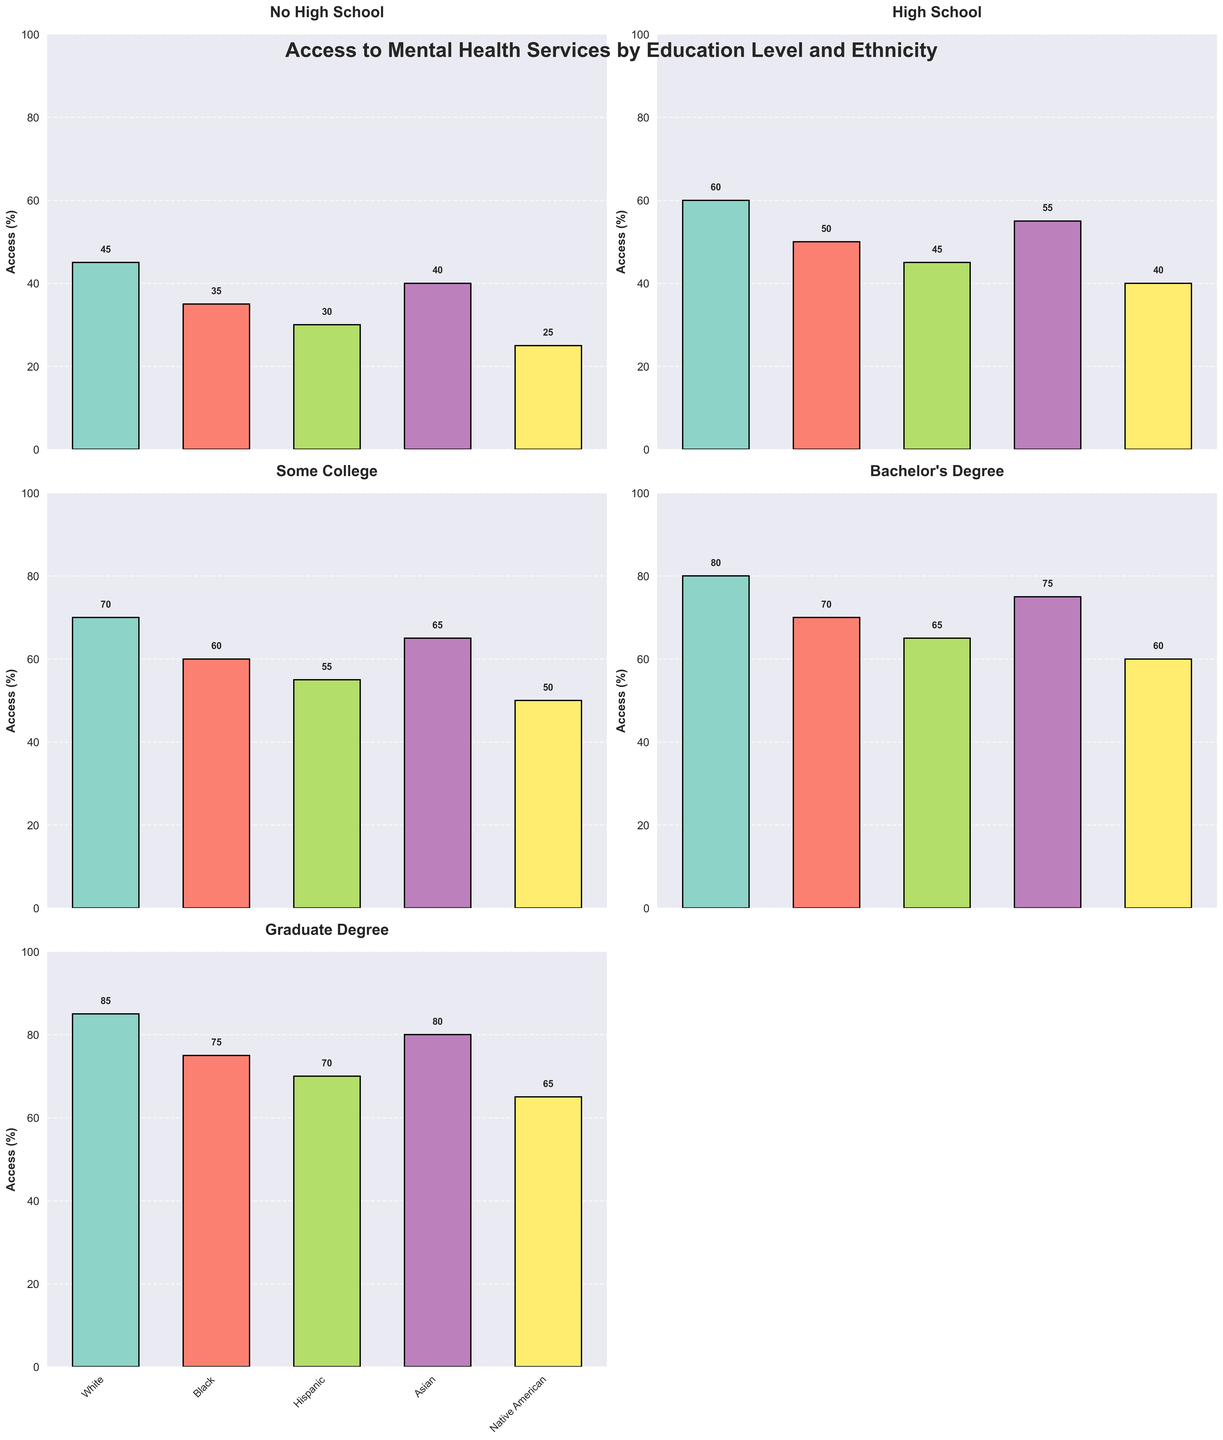Which ethnic group with a High School education level has the lowest access to mental health services? To determine this, we find the ethnic group within the "High School" education level category. Among these, the Native American group has the lowest access rate, as indicated by the shortest bar.
Answer: Native American How does the access to mental health services for Black individuals with a Bachelor's Degree compare to those with a Graduate Degree? By comparing the height of the bars, we see that Black individuals with a Bachelor's Degree have an access rate of 70%, while those with a Graduate Degree have a rate of 75%.
Answer: Graduate Degree is higher Which education level shows the smallest difference in access to mental health services between White and Asian ethnicities? Calculate the difference for each education level: No High School (5), High School (5), Some College (5), Bachelor's Degree (5), and Graduate Degree (5). The differences are the same at all levels.
Answer: All levels are the same What is the overall trend in access to mental health services as education level increases for Hispanic individuals? Observing the Hispanic bars across the different subplots, we see that access increases consistently: No High School (30%), High School (45%), Some College (55%), Bachelor's Degree (65%), and Graduate Degree (70%).
Answer: Increasing trend Which ethnic group shows the highest access rate at the Some College education level, and what is that rate? At the Some College education level, the White ethnic group has the highest access rate, as indicated by the tallest bar among these groups, and the rate is 70%.
Answer: White, 70% By how much does access to mental health services for Native American individuals increase from No High School to Graduate Degree? For Native American individuals, access rates are 25% for No High School and 65% for Graduate Degree. The increase is calculated by 65% - 25% = 40%.
Answer: 40% Compare the access to mental health services for Asian individuals with a High School education versus those with a Bachelor's Degree. For Asian individuals, the access rate is 55% with a High School education and 75% with a Bachelor's Degree. The difference is 75% - 55% = 20%.
Answer: 20% Which education level and ethnic group combination shows the greatest disparity in access rates compared to the corresponding White group? Compute differences for each group at each level: e.g., No High School: White (45%) vs. Native American (25%) = 20%, and so forth. The greatest disparity is between White (85%) and Native American (65%) at the Graduate Degree level, a difference of 20%.
Answer: Graduate Degree, Native American, 20% 